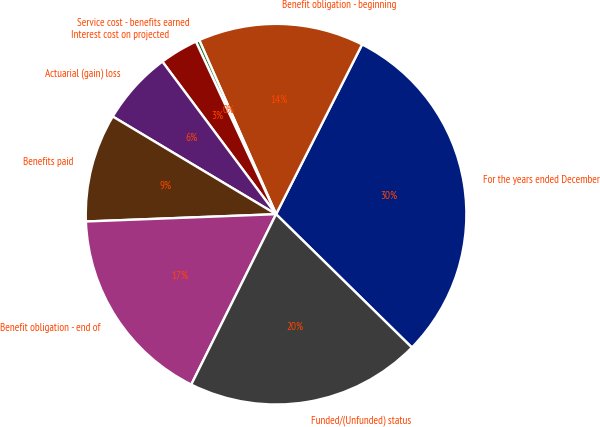Convert chart. <chart><loc_0><loc_0><loc_500><loc_500><pie_chart><fcel>For the years ended December<fcel>Benefit obligation - beginning<fcel>Service cost - benefits earned<fcel>Interest cost on projected<fcel>Actuarial (gain) loss<fcel>Benefits paid<fcel>Benefit obligation - end of<fcel>Funded/(Unfunded) status<nl><fcel>29.89%<fcel>14.08%<fcel>0.31%<fcel>3.27%<fcel>6.23%<fcel>9.19%<fcel>17.04%<fcel>20.0%<nl></chart> 